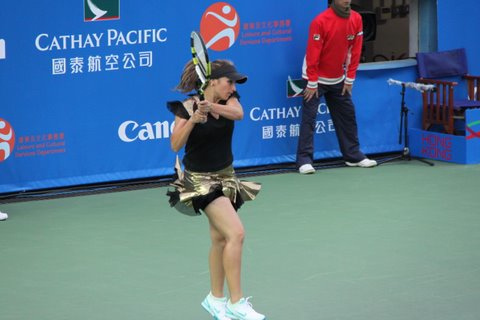<image>What car brand has a sponsor banner on the wall? It is ambiguous to determine the car brand that has a sponsor banner on the wall. It could potentially be 'cathay pacific', 'ford', 'camry' or none at all. In what country is this event? I am not sure in what country this event is. It can be in 'hong kong', 'china', 'japan' or 'usa'. In what country is this event? I am not sure in what country is this event. However, it can be in Hong Kong, China, Japan, the US, or the USA. What car brand has a sponsor banner on the wall? I don't know what car brand has a sponsor banner on the wall. It can be 'cathay', 'cathay pacific', 'ford', or 'camry'. 